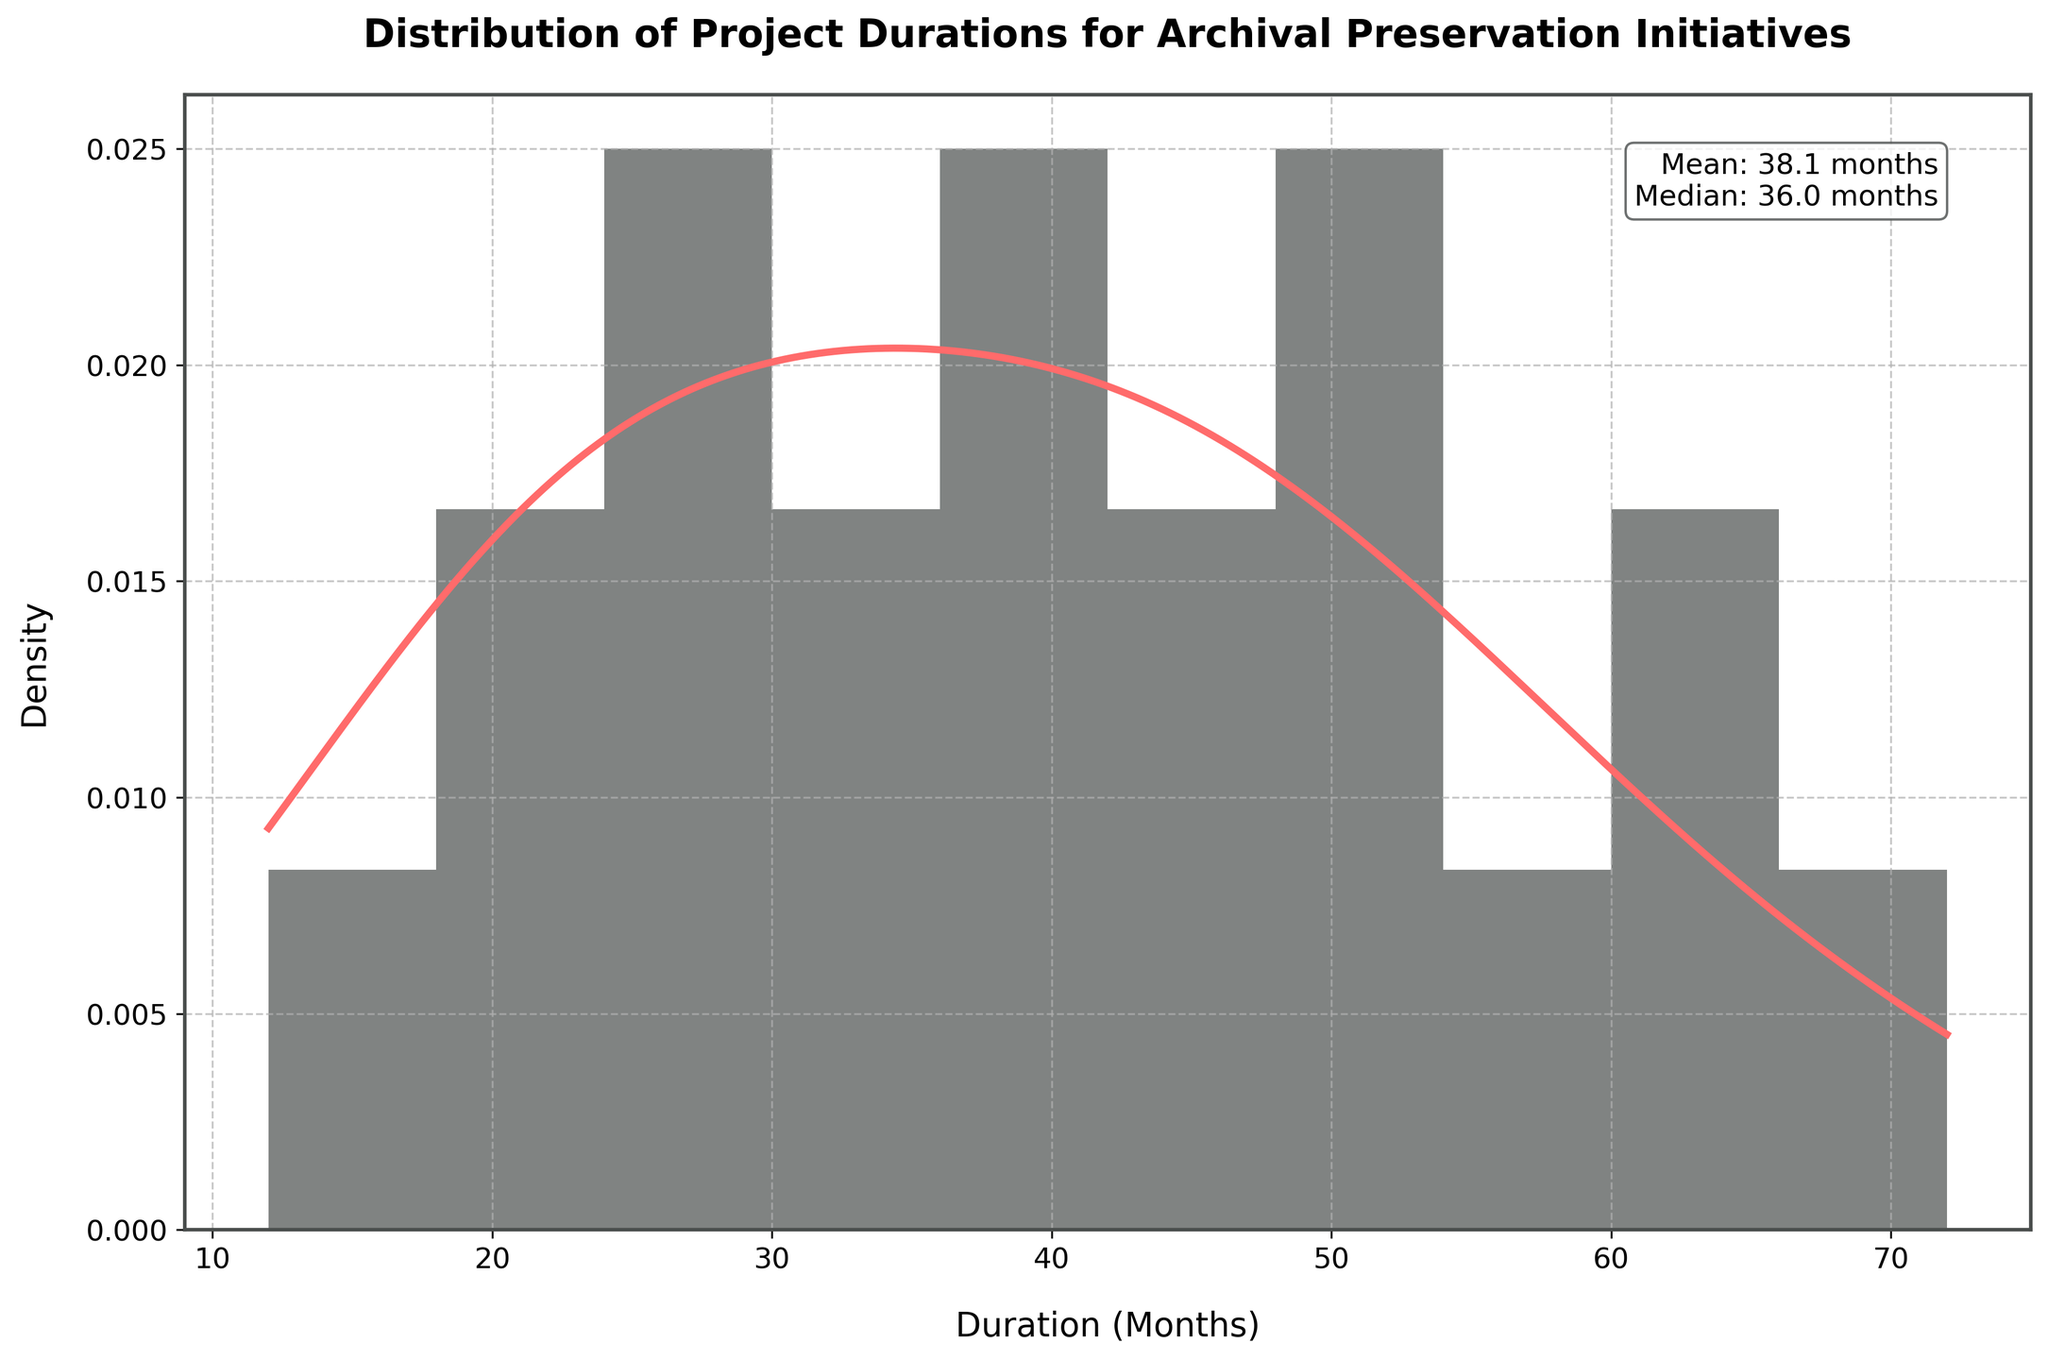What is the title of the plot? The title is located at the top of the plot, written in bold and large font. It reads "Distribution of Project Durations for Archival Preservation Initiatives," which provides context for the data being visualized.
Answer: Distribution of Project Durations for Archival Preservation Initiatives Which color is used for the histogram bars? The histogram bars are colored in a specific shade that is darker than the density curve, making them distinguishable.
Answer: Dark grey What is the approximate range of project durations shown in the histogram? To find the range, look at the x-axis, which shows the duration in months, and note the minimum and maximum values between which the data is distributed.
Answer: 12 to 72 months What are the mean and median project durations? This information is presented in a text box within the plot. The mean and median values are given as calculated statistics for the duration data.
Answer: Mean: 37.5 months, Median: 36 months Which project duration has the highest density according to the KDE curve? To determine this, identify the peak of the KDE curve and note the corresponding duration value on the x-axis. The higher the peak, the higher the density for that duration.
Answer: Around 48 months How many bins does the histogram use to display the data? Count the number of individual bars (bins) present in the histogram along the x-axis.
Answer: 10 Which duration range appears to have the fewest projects? Observe the histogram and identify the bin with the shortest bar height, indicating fewer projects within that duration range.
Answer: 66 to 72 months Are there more projects with durations shorter than or longer than the mean duration? Compare the count of projects in histogram bars to the left and right of the mean duration (37.5 months). Find the side with the higher count/density.
Answer: Shorter than the mean duration What is the total range (difference) of project durations? Calculate the difference between the maximum and minimum project durations. The minimum is 12 months and the maximum is 72 months.
Answer: 60 months How does the spacing of the KDE curve compare to the histogram bars? Assess whether the KDE curve is smooth and continuous versus the discrete nature of histogram bars. This visually shows the relationship in data density across durations.
Answer: KDE curve is smoother and continuous 